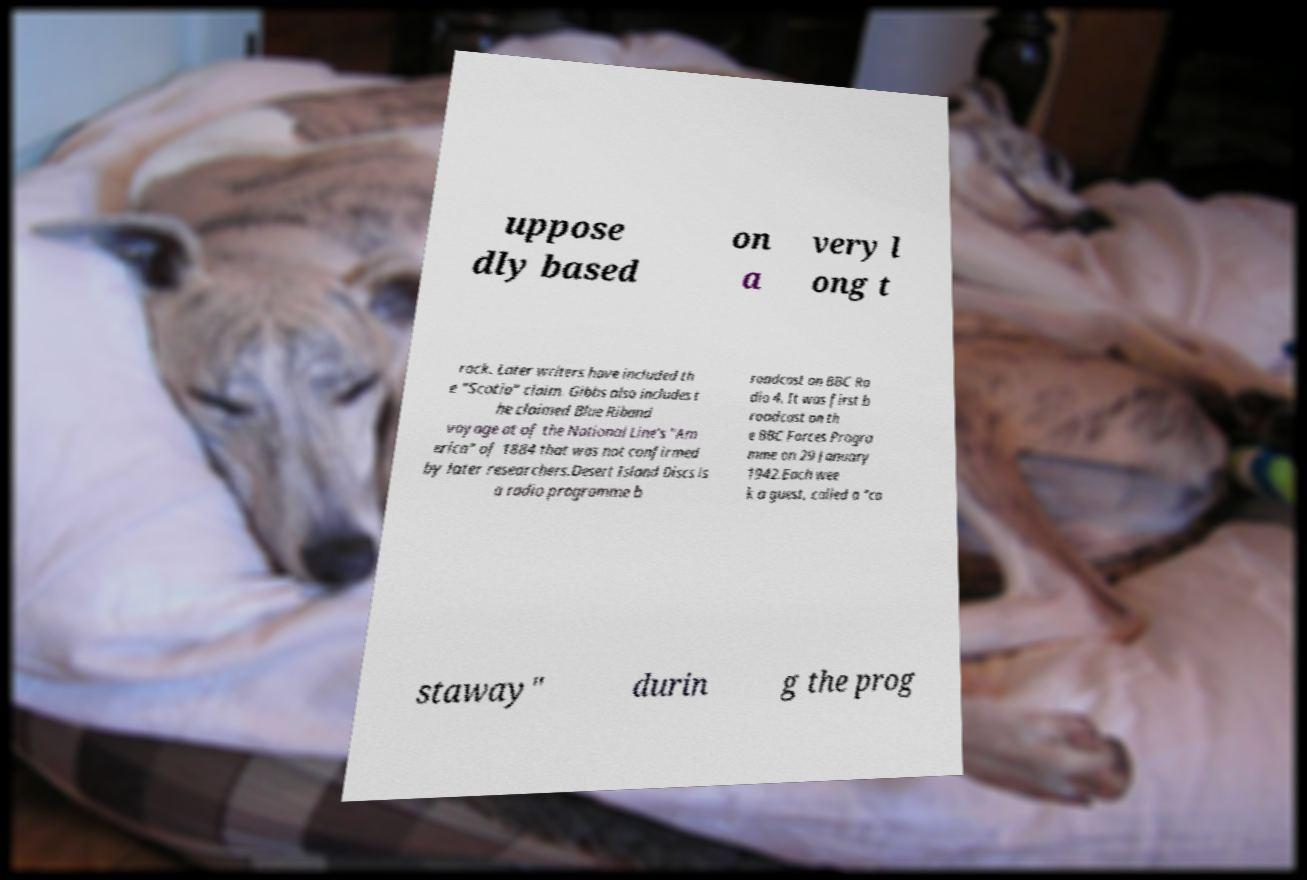Can you read and provide the text displayed in the image?This photo seems to have some interesting text. Can you extract and type it out for me? uppose dly based on a very l ong t rack. Later writers have included th e "Scotia" claim. Gibbs also includes t he claimed Blue Riband voyage at of the National Line's "Am erica" of 1884 that was not confirmed by later researchers.Desert Island Discs is a radio programme b roadcast on BBC Ra dio 4. It was first b roadcast on th e BBC Forces Progra mme on 29 January 1942.Each wee k a guest, called a "ca staway" durin g the prog 